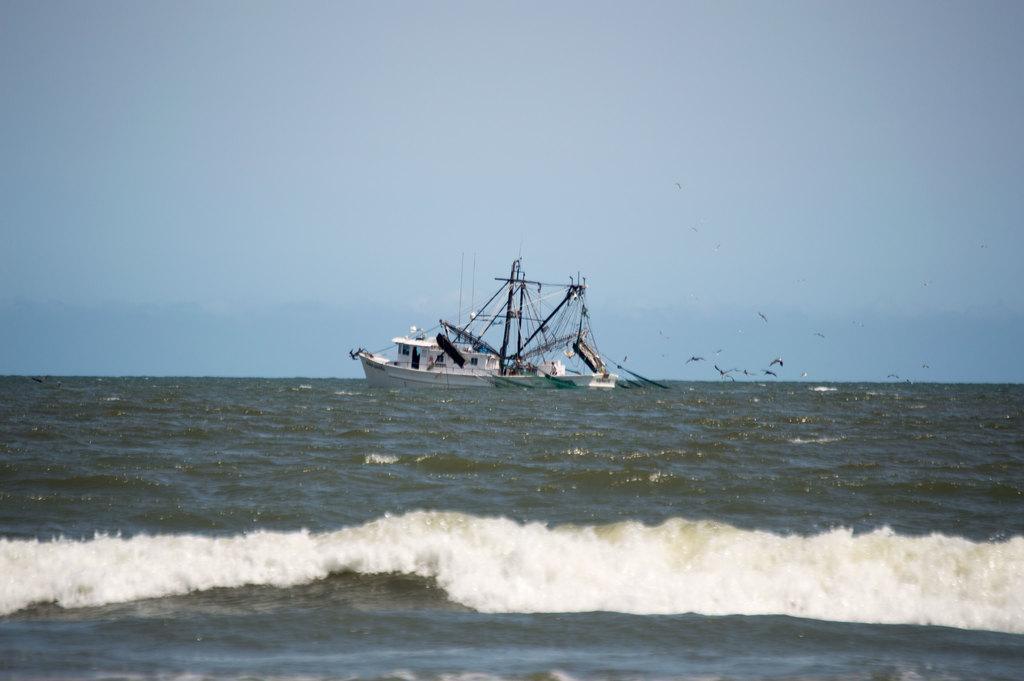Please provide a concise description of this image. In this image we can see a boat on the water. In the background there is sky. 